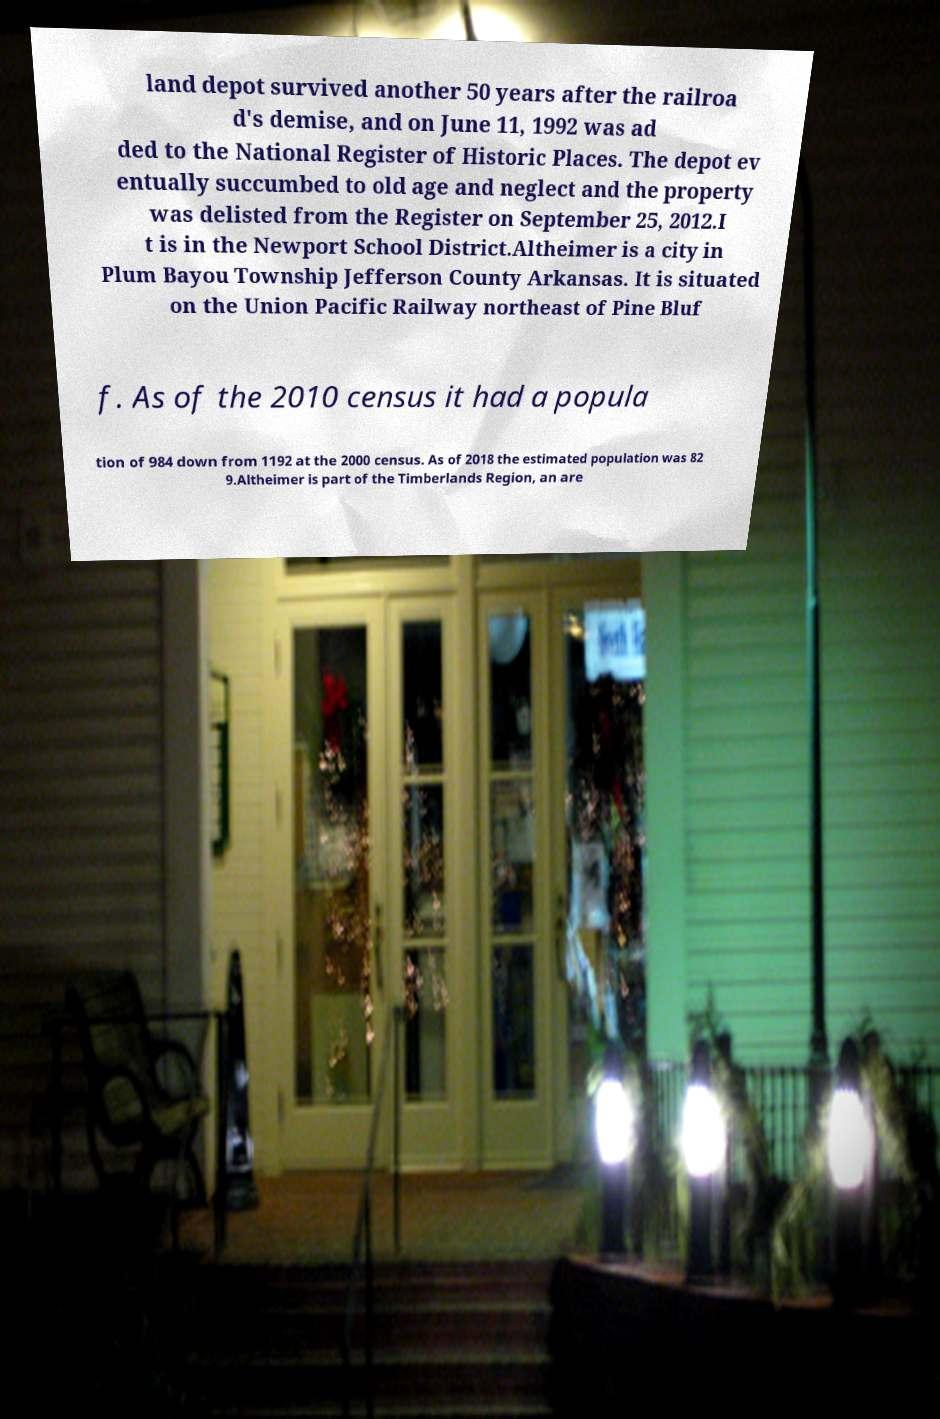Could you assist in decoding the text presented in this image and type it out clearly? land depot survived another 50 years after the railroa d's demise, and on June 11, 1992 was ad ded to the National Register of Historic Places. The depot ev entually succumbed to old age and neglect and the property was delisted from the Register on September 25, 2012.I t is in the Newport School District.Altheimer is a city in Plum Bayou Township Jefferson County Arkansas. It is situated on the Union Pacific Railway northeast of Pine Bluf f. As of the 2010 census it had a popula tion of 984 down from 1192 at the 2000 census. As of 2018 the estimated population was 82 9.Altheimer is part of the Timberlands Region, an are 